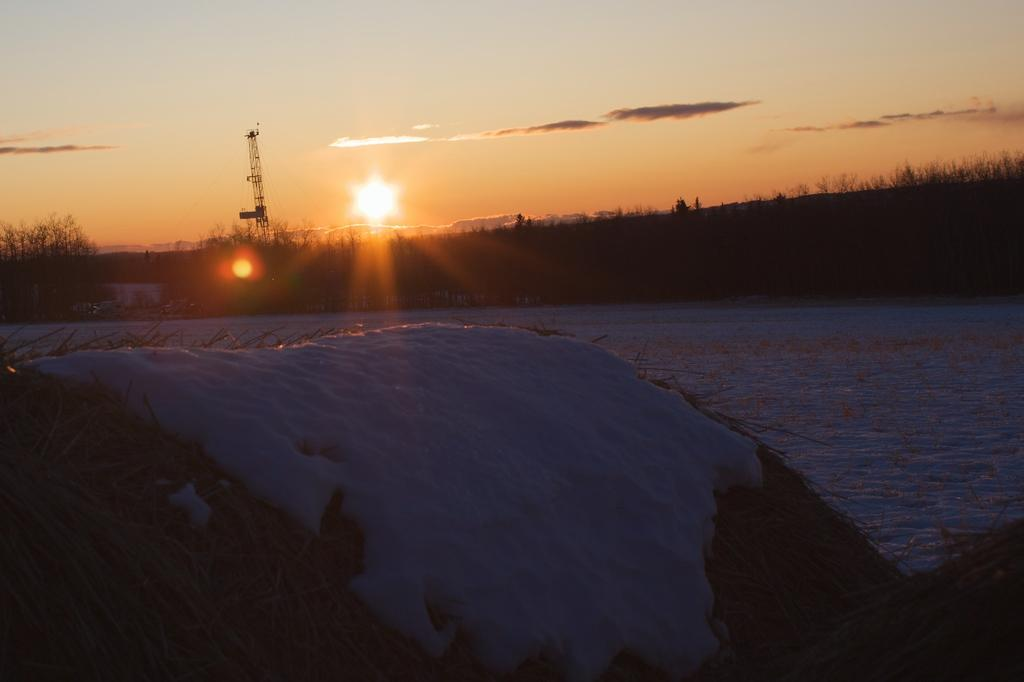What type of vegetation can be seen in the image? There is dry grass in the image. What weather condition is depicted in the image? There is snow in the image. What structure is visible in the image? There is a tower visible in the image. What natural element is present in the image? There is water in the image. What celestial body is visible in the image? The sun is visible in the image. What type of plant life is present in the image? There are trees in the image. What is the color of the sky in the image? The sky is a combination of white and orange colors in the image. How many bikes are parked near the trees in the image? There are no bikes present in the image. Are the brothers playing in the snow near the tower in the image? There is no mention of brothers or their activities in the image. 